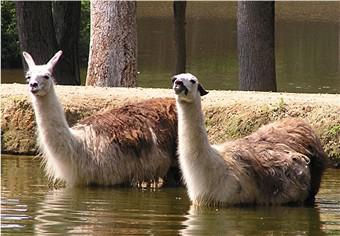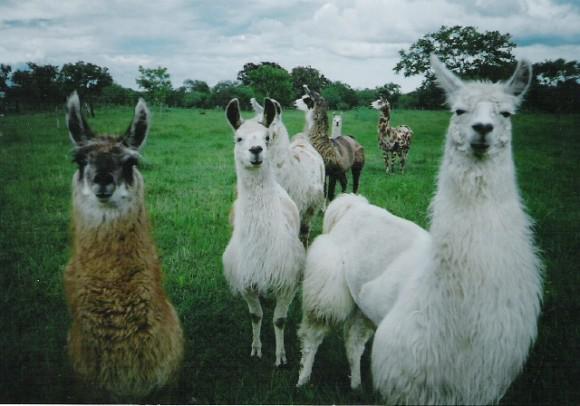The first image is the image on the left, the second image is the image on the right. For the images displayed, is the sentence "The llamas in the left image are looking in opposite directions." factually correct? Answer yes or no. No. The first image is the image on the left, the second image is the image on the right. For the images displayed, is the sentence "The left image shows a small white llama standing alongside a taller white llama, both with bodies facing forward." factually correct? Answer yes or no. No. 